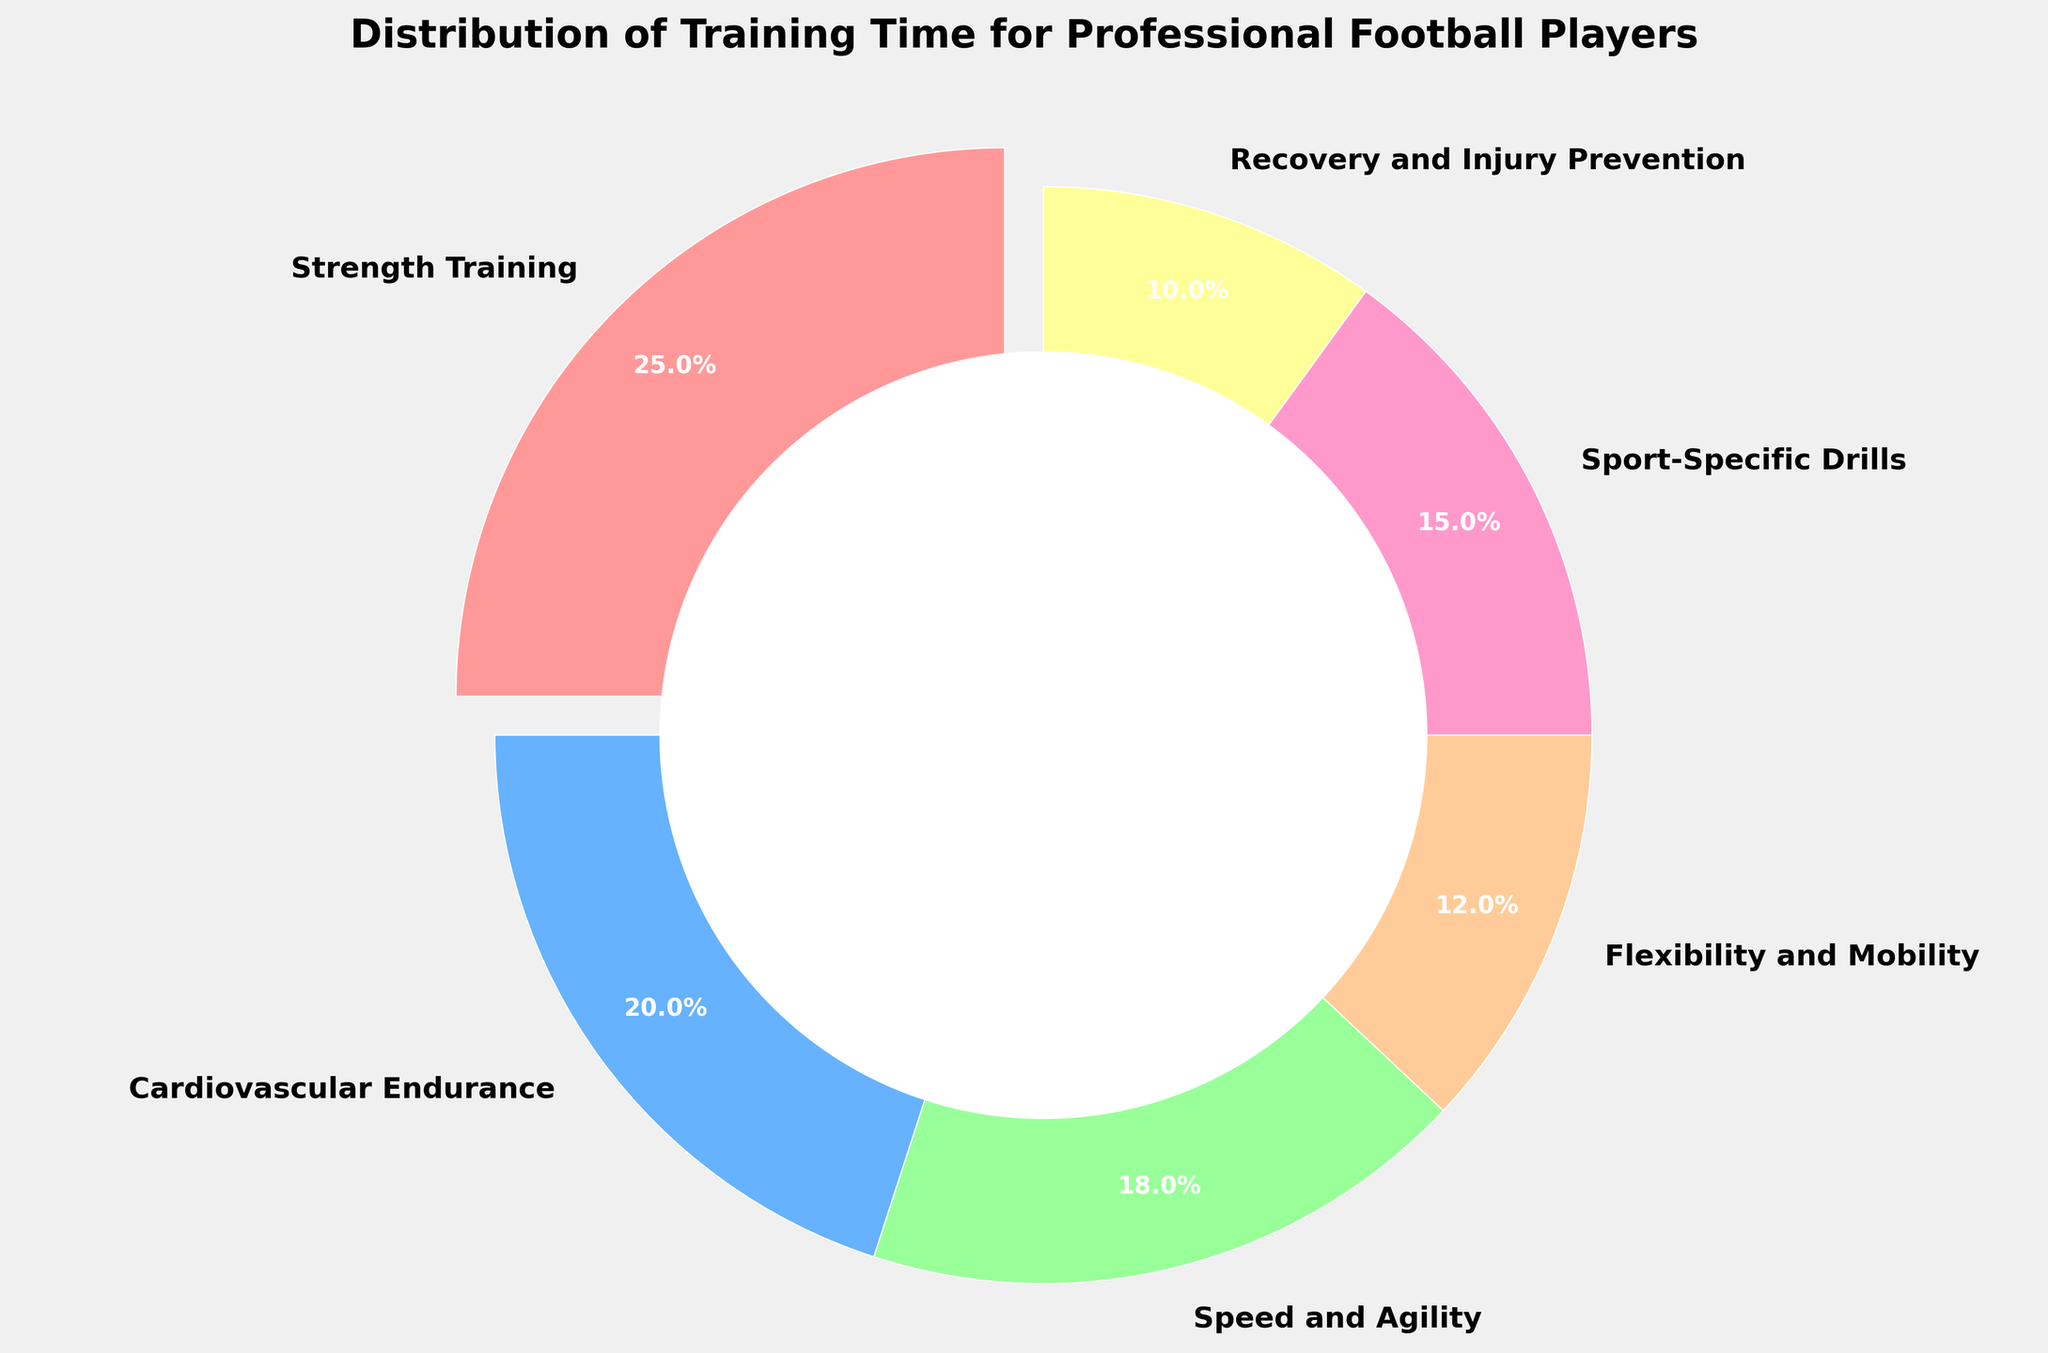What percentage of training time is dedicated to recovery and injury prevention? Locate the segment labeled "Recovery and Injury Prevention" and read its corresponding percentage.
Answer: 10% Which fitness component receives the most training time? Observe the pie chart and identify the segment with the largest percentage value.
Answer: Strength Training How much more training time is allocated to strength training compared to flexibility and mobility? Subtract the percentage of Flexibility and Mobility from the percentage of Strength Training (25% - 12%).
Answer: 13% Is the time dedicated to cardiovascular endurance greater or lesser than sport-specific drills? Compare the percentage values of Cardiovascular Endurance and Sport-Specific Drills.
Answer: Greater What is the total percentage of training time allocated to speed and agility and flexibility and mobility combined? Add the percentages of Speed and Agility and Flexibility and Mobility (18% + 12%).
Answer: 30% Identify the segments colored in red and blue. What components do they represent? Match the colors red and blue to their respective labeled segments on the pie chart.
Answer: Strength Training, Cardiovascular Endurance Which two components together account for less than one-third of the total training time? Identify percentages of different components and combine them to find pairs that total less than 33% (Flexibility and Mobility, Recovery and Injury Prevention; 12% + 10%).
Answer: Flexibility and Mobility, Recovery and Injury Prevention What is the difference in training time between speed and agility and recovery and injury prevention? Subtract the percentage of Recovery and Injury Prevention from the percentage of Speed and Agility (18% - 10%).
Answer: 8% What is the smallest segment on the pie chart and its percentage? Identify the smallest segment visually and read its corresponding percentage.
Answer: Recovery and Injury Prevention, 10% How do the time distributions for sport-specific drills and recovery and injury prevention compare? Compare the percentage values of Sport-Specific Drills and Recovery and Injury Prevention.
Answer: Sport-Specific Drills is higher 